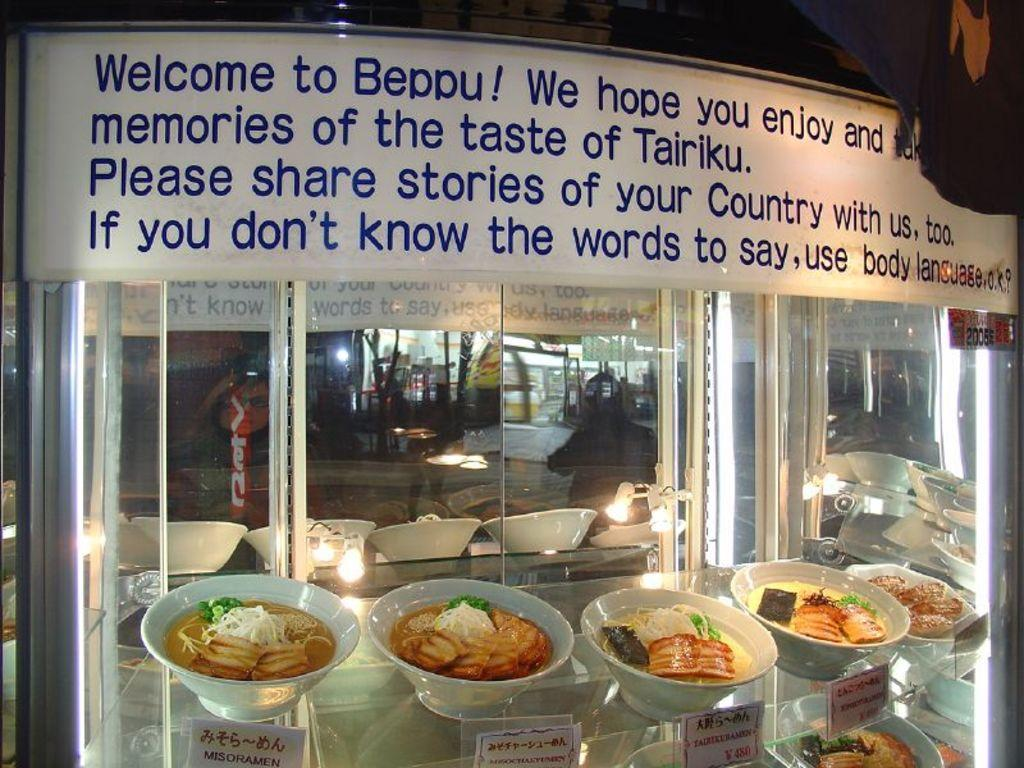What type of furniture is present in the image? There is a display cabinet in the image. What is inside the display cabinet? The display cabinet contains food bowls. Is there any text visible in the image? Yes, there is some text visible in the image. What type of test is being conducted in the image? There is no test being conducted in the image; it features a display cabinet with food bowls and some text. What holiday is being celebrated in the image? There is no indication of a holiday being celebrated in the image. 